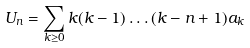<formula> <loc_0><loc_0><loc_500><loc_500>U _ { n } = \sum _ { k \geq 0 } k ( k - 1 ) \dots ( k - n + 1 ) a _ { k }</formula> 